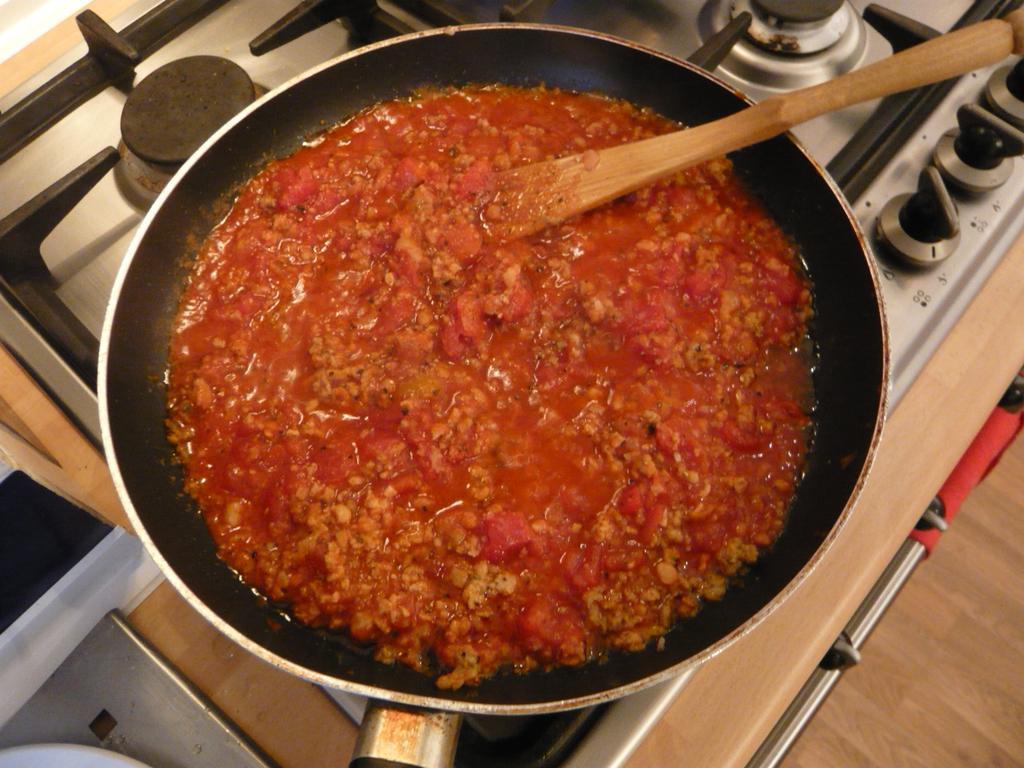Describe this image in one or two sentences. In this image, I can see a frying pan, which is placed on the stove. This frying pan contains food item. I think this is a wooden serving spoon. 